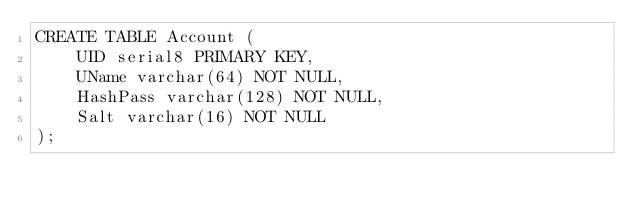Convert code to text. <code><loc_0><loc_0><loc_500><loc_500><_SQL_>CREATE TABLE Account (
    UID serial8 PRIMARY KEY,
    UName varchar(64) NOT NULL,
    HashPass varchar(128) NOT NULL,
    Salt varchar(16) NOT NULL
);
</code> 